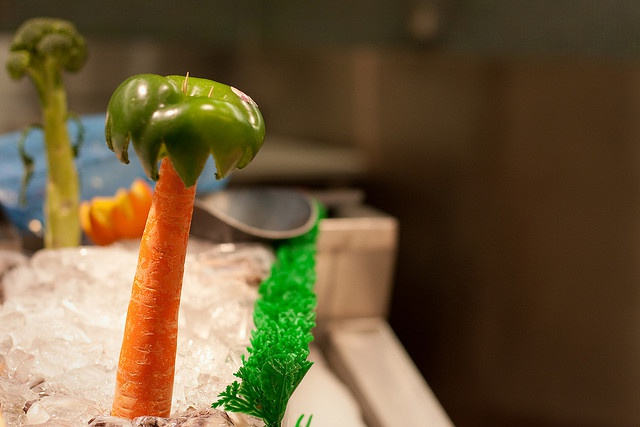Describe the objects in this image and their specific colors. I can see carrot in black, brown, red, and orange tones, broccoli in black, olive, and tan tones, and bowl in black, gray, and maroon tones in this image. 